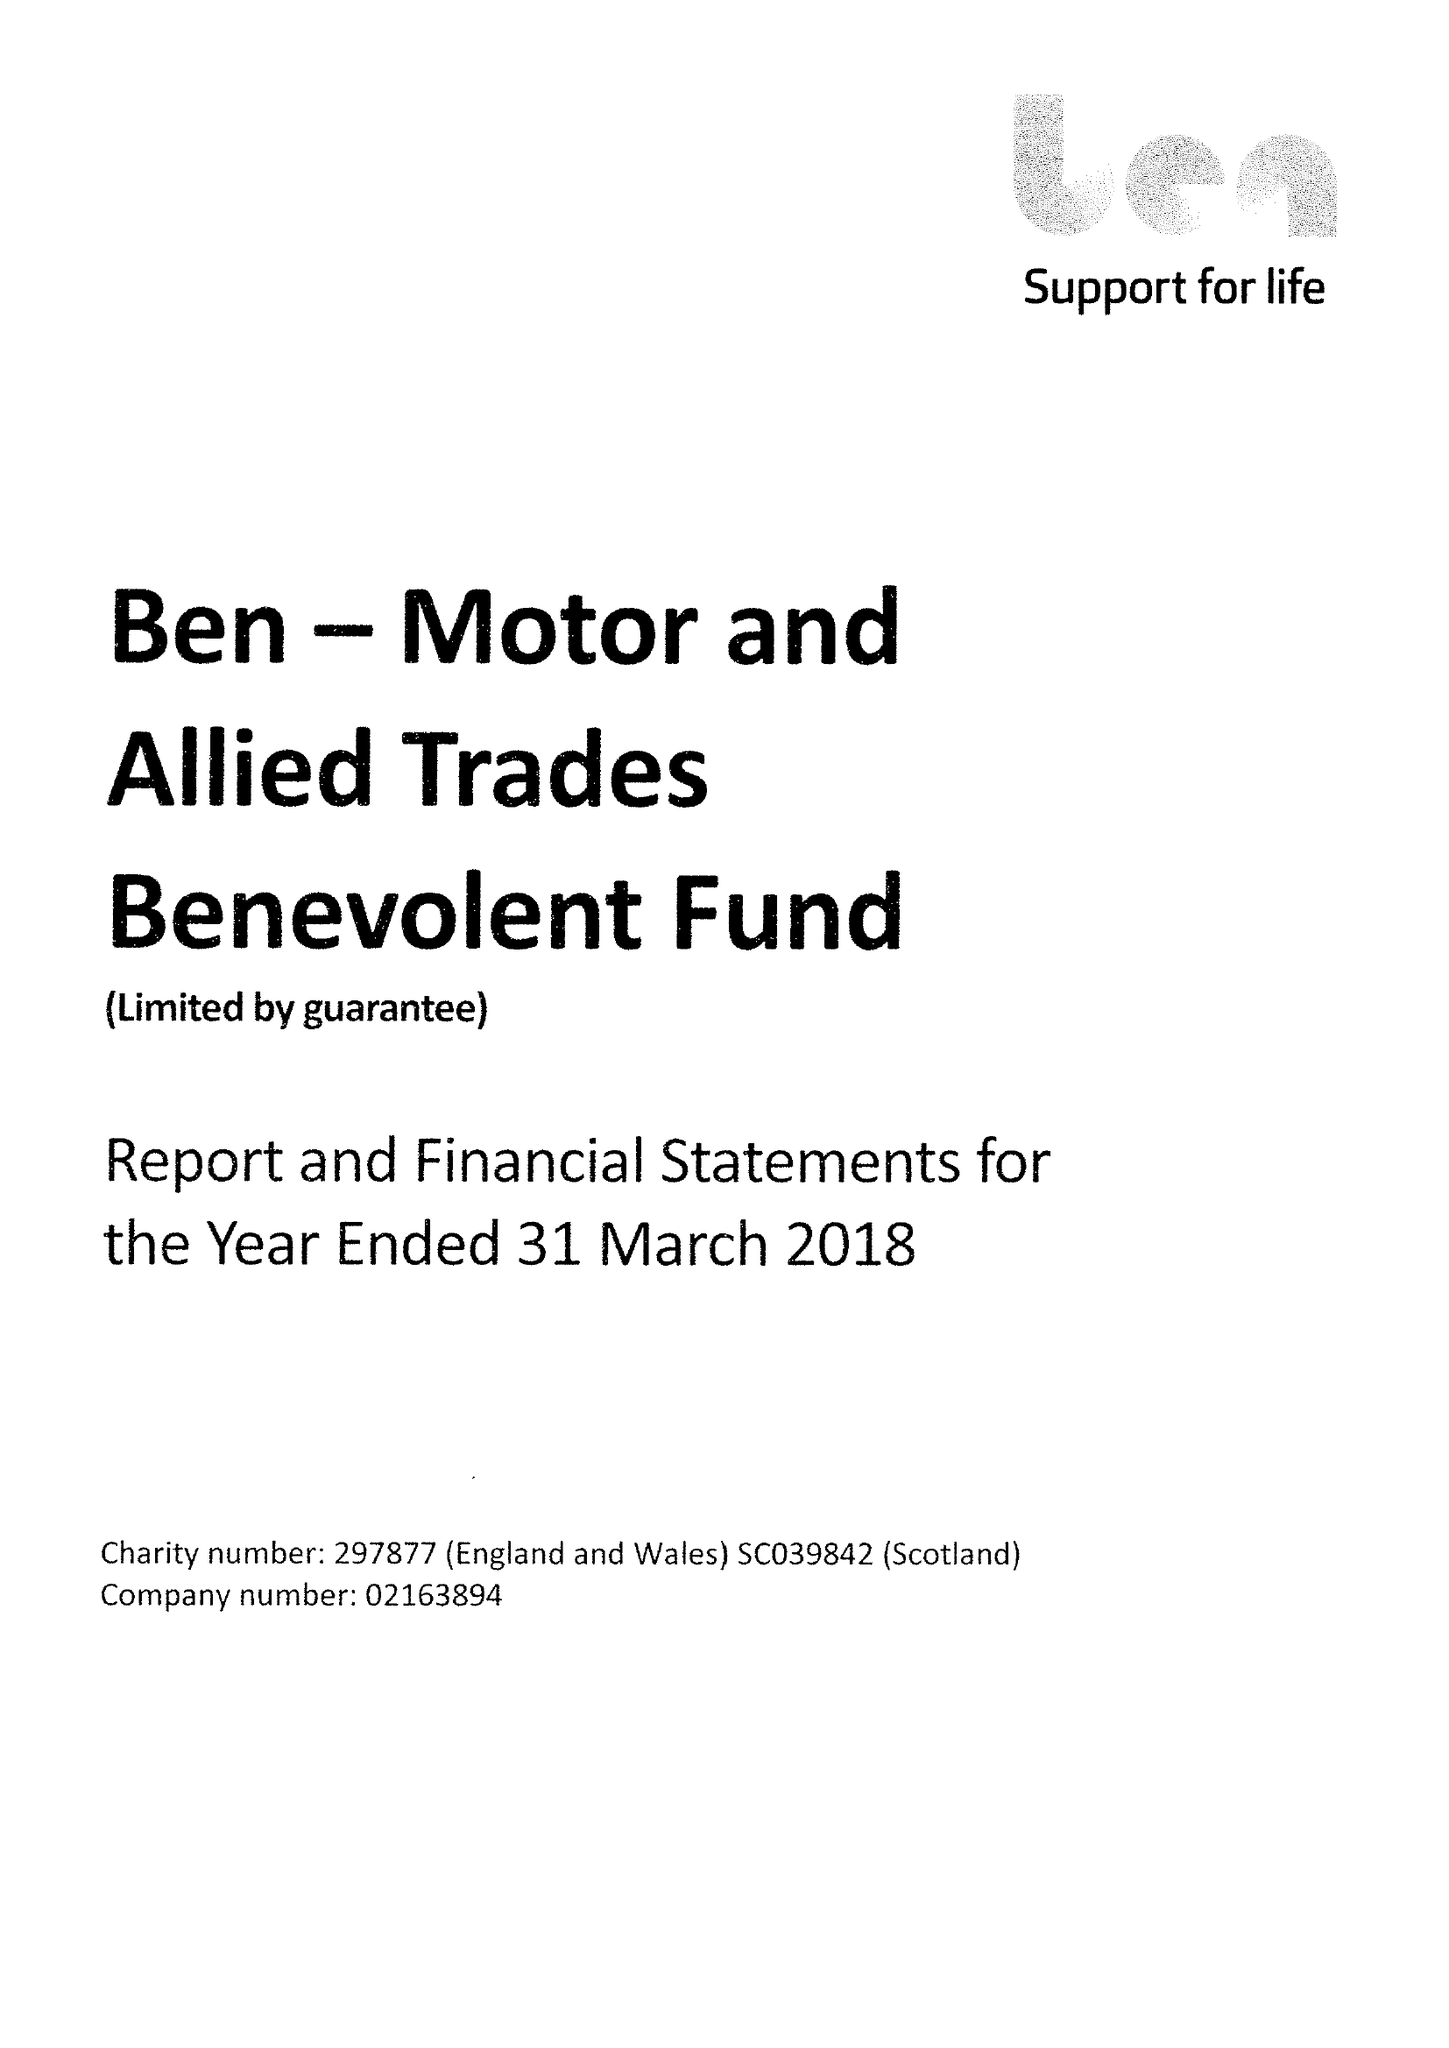What is the value for the address__street_line?
Answer the question using a single word or phrase. RISE ROAD 